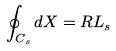Convert formula to latex. <formula><loc_0><loc_0><loc_500><loc_500>\oint _ { C _ { s } } d X = R L _ { s }</formula> 